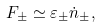Convert formula to latex. <formula><loc_0><loc_0><loc_500><loc_500>F _ { \pm } \simeq \varepsilon _ { \pm } \dot { n } _ { \pm } ,</formula> 